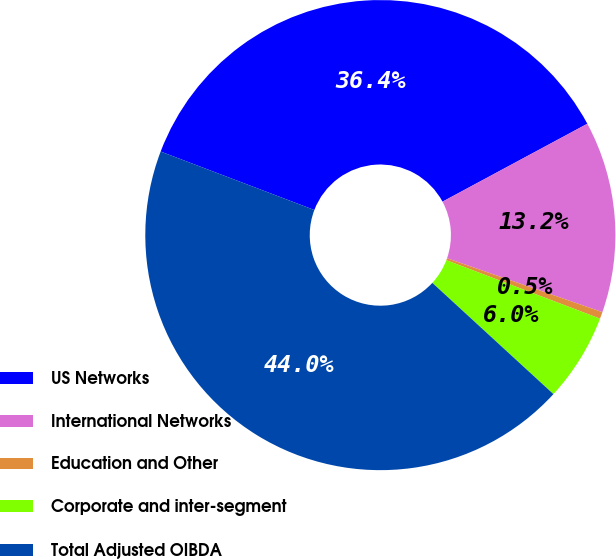Convert chart. <chart><loc_0><loc_0><loc_500><loc_500><pie_chart><fcel>US Networks<fcel>International Networks<fcel>Education and Other<fcel>Corporate and inter-segment<fcel>Total Adjusted OIBDA<nl><fcel>36.36%<fcel>13.17%<fcel>0.47%<fcel>6.04%<fcel>43.96%<nl></chart> 